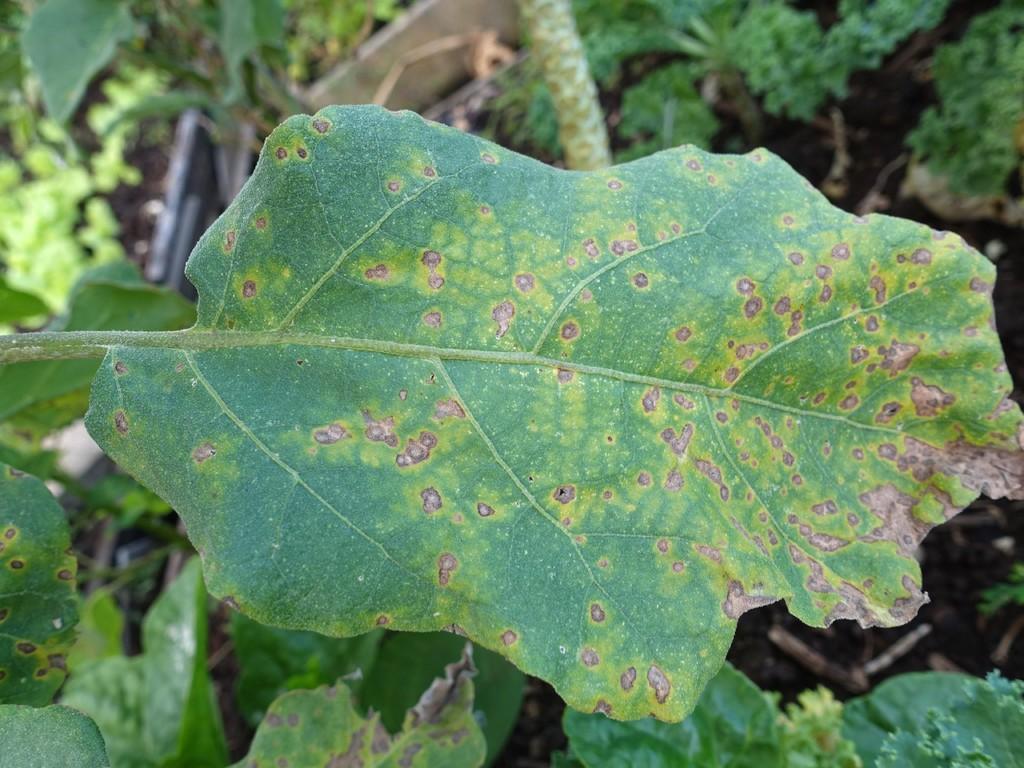Could you give a brief overview of what you see in this image? In this picture we can see plants and some objects on the ground. 